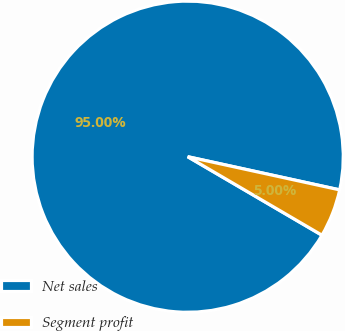Convert chart. <chart><loc_0><loc_0><loc_500><loc_500><pie_chart><fcel>Net sales<fcel>Segment profit<nl><fcel>95.0%<fcel>5.0%<nl></chart> 